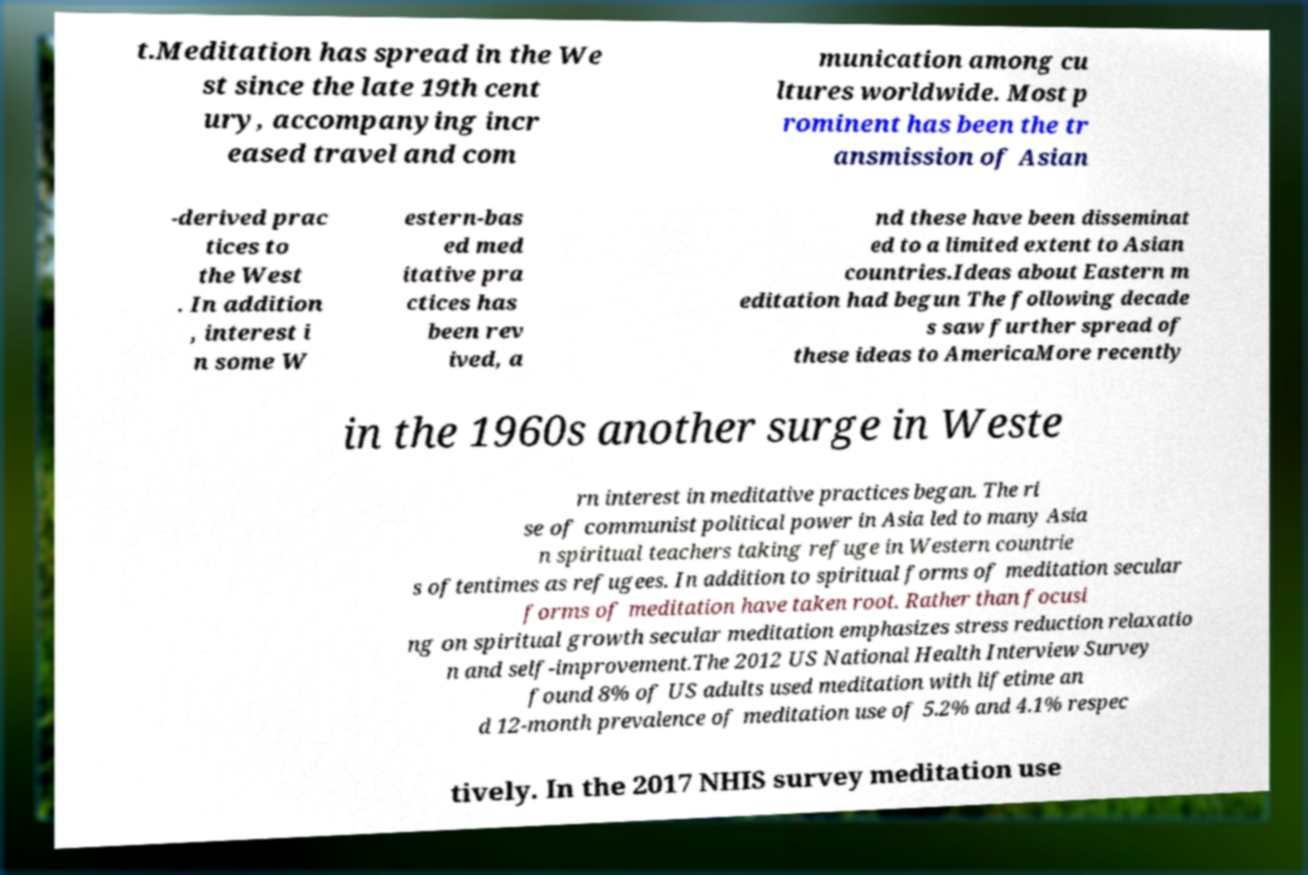There's text embedded in this image that I need extracted. Can you transcribe it verbatim? t.Meditation has spread in the We st since the late 19th cent ury, accompanying incr eased travel and com munication among cu ltures worldwide. Most p rominent has been the tr ansmission of Asian -derived prac tices to the West . In addition , interest i n some W estern-bas ed med itative pra ctices has been rev ived, a nd these have been disseminat ed to a limited extent to Asian countries.Ideas about Eastern m editation had begun The following decade s saw further spread of these ideas to AmericaMore recently in the 1960s another surge in Weste rn interest in meditative practices began. The ri se of communist political power in Asia led to many Asia n spiritual teachers taking refuge in Western countrie s oftentimes as refugees. In addition to spiritual forms of meditation secular forms of meditation have taken root. Rather than focusi ng on spiritual growth secular meditation emphasizes stress reduction relaxatio n and self-improvement.The 2012 US National Health Interview Survey found 8% of US adults used meditation with lifetime an d 12-month prevalence of meditation use of 5.2% and 4.1% respec tively. In the 2017 NHIS survey meditation use 